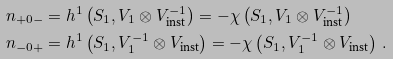Convert formula to latex. <formula><loc_0><loc_0><loc_500><loc_500>n _ { + 0 - } & = h ^ { 1 } \left ( S _ { 1 } , V _ { 1 } \otimes V _ { \text {inst} } ^ { - 1 } \right ) = - \chi \left ( S _ { 1 } , V _ { 1 } \otimes V _ { \text {inst} } ^ { - 1 } \right ) \\ n _ { - 0 + } & = h ^ { 1 } \left ( S _ { 1 } , V _ { 1 } ^ { - 1 } \otimes V _ { \text {inst} } \right ) = - \chi \left ( S _ { 1 } , V _ { 1 } ^ { - 1 } \otimes V _ { \text {inst} } \right ) \, .</formula> 